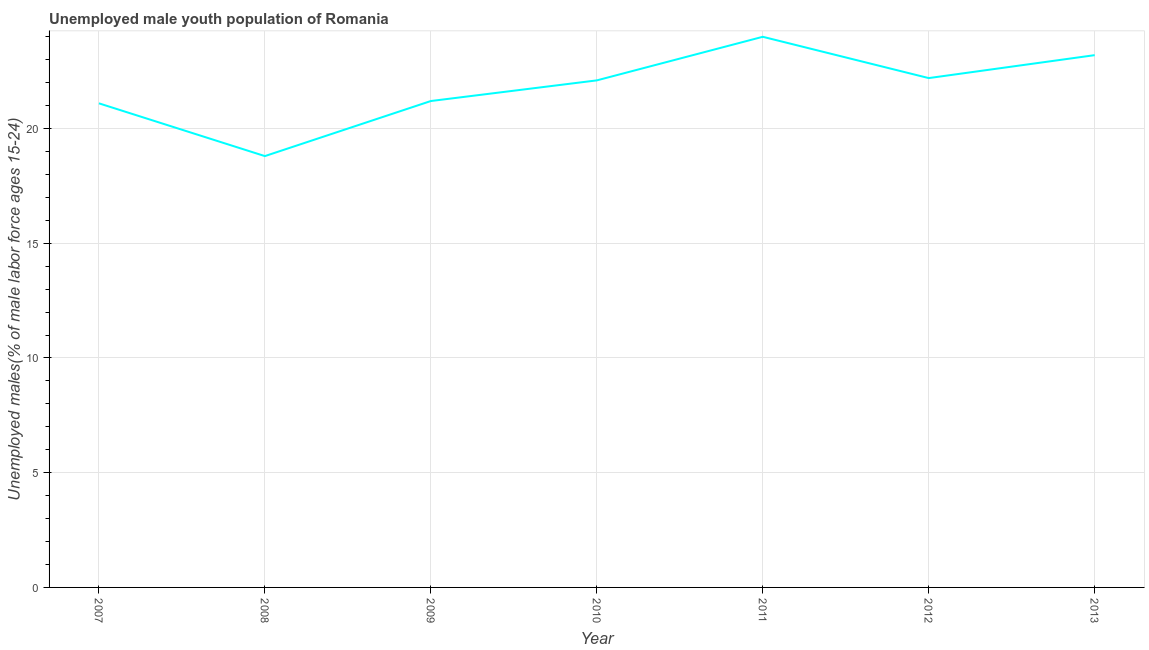What is the unemployed male youth in 2010?
Ensure brevity in your answer.  22.1. Across all years, what is the minimum unemployed male youth?
Offer a terse response. 18.8. What is the sum of the unemployed male youth?
Keep it short and to the point. 152.6. What is the difference between the unemployed male youth in 2008 and 2011?
Your answer should be compact. -5.2. What is the average unemployed male youth per year?
Keep it short and to the point. 21.8. What is the median unemployed male youth?
Ensure brevity in your answer.  22.1. In how many years, is the unemployed male youth greater than 21 %?
Provide a short and direct response. 6. What is the ratio of the unemployed male youth in 2010 to that in 2013?
Make the answer very short. 0.95. Is the unemployed male youth in 2007 less than that in 2011?
Provide a succinct answer. Yes. Is the difference between the unemployed male youth in 2011 and 2012 greater than the difference between any two years?
Keep it short and to the point. No. What is the difference between the highest and the second highest unemployed male youth?
Offer a terse response. 0.8. Is the sum of the unemployed male youth in 2011 and 2012 greater than the maximum unemployed male youth across all years?
Provide a succinct answer. Yes. What is the difference between the highest and the lowest unemployed male youth?
Make the answer very short. 5.2. Does the unemployed male youth monotonically increase over the years?
Provide a short and direct response. No. How many lines are there?
Provide a short and direct response. 1. How many years are there in the graph?
Your response must be concise. 7. What is the title of the graph?
Keep it short and to the point. Unemployed male youth population of Romania. What is the label or title of the Y-axis?
Offer a very short reply. Unemployed males(% of male labor force ages 15-24). What is the Unemployed males(% of male labor force ages 15-24) in 2007?
Provide a short and direct response. 21.1. What is the Unemployed males(% of male labor force ages 15-24) in 2008?
Your answer should be very brief. 18.8. What is the Unemployed males(% of male labor force ages 15-24) in 2009?
Keep it short and to the point. 21.2. What is the Unemployed males(% of male labor force ages 15-24) of 2010?
Your answer should be very brief. 22.1. What is the Unemployed males(% of male labor force ages 15-24) of 2011?
Ensure brevity in your answer.  24. What is the Unemployed males(% of male labor force ages 15-24) in 2012?
Keep it short and to the point. 22.2. What is the Unemployed males(% of male labor force ages 15-24) in 2013?
Ensure brevity in your answer.  23.2. What is the difference between the Unemployed males(% of male labor force ages 15-24) in 2007 and 2008?
Your response must be concise. 2.3. What is the difference between the Unemployed males(% of male labor force ages 15-24) in 2007 and 2009?
Your answer should be very brief. -0.1. What is the difference between the Unemployed males(% of male labor force ages 15-24) in 2007 and 2010?
Provide a short and direct response. -1. What is the difference between the Unemployed males(% of male labor force ages 15-24) in 2007 and 2011?
Provide a succinct answer. -2.9. What is the difference between the Unemployed males(% of male labor force ages 15-24) in 2008 and 2009?
Offer a very short reply. -2.4. What is the difference between the Unemployed males(% of male labor force ages 15-24) in 2008 and 2010?
Ensure brevity in your answer.  -3.3. What is the difference between the Unemployed males(% of male labor force ages 15-24) in 2008 and 2013?
Give a very brief answer. -4.4. What is the difference between the Unemployed males(% of male labor force ages 15-24) in 2009 and 2011?
Offer a very short reply. -2.8. What is the difference between the Unemployed males(% of male labor force ages 15-24) in 2010 and 2011?
Your response must be concise. -1.9. What is the difference between the Unemployed males(% of male labor force ages 15-24) in 2012 and 2013?
Your response must be concise. -1. What is the ratio of the Unemployed males(% of male labor force ages 15-24) in 2007 to that in 2008?
Ensure brevity in your answer.  1.12. What is the ratio of the Unemployed males(% of male labor force ages 15-24) in 2007 to that in 2009?
Offer a terse response. 0.99. What is the ratio of the Unemployed males(% of male labor force ages 15-24) in 2007 to that in 2010?
Offer a very short reply. 0.95. What is the ratio of the Unemployed males(% of male labor force ages 15-24) in 2007 to that in 2011?
Provide a succinct answer. 0.88. What is the ratio of the Unemployed males(% of male labor force ages 15-24) in 2007 to that in 2013?
Provide a succinct answer. 0.91. What is the ratio of the Unemployed males(% of male labor force ages 15-24) in 2008 to that in 2009?
Offer a terse response. 0.89. What is the ratio of the Unemployed males(% of male labor force ages 15-24) in 2008 to that in 2010?
Your answer should be very brief. 0.85. What is the ratio of the Unemployed males(% of male labor force ages 15-24) in 2008 to that in 2011?
Offer a terse response. 0.78. What is the ratio of the Unemployed males(% of male labor force ages 15-24) in 2008 to that in 2012?
Offer a terse response. 0.85. What is the ratio of the Unemployed males(% of male labor force ages 15-24) in 2008 to that in 2013?
Give a very brief answer. 0.81. What is the ratio of the Unemployed males(% of male labor force ages 15-24) in 2009 to that in 2011?
Provide a succinct answer. 0.88. What is the ratio of the Unemployed males(% of male labor force ages 15-24) in 2009 to that in 2012?
Your answer should be very brief. 0.95. What is the ratio of the Unemployed males(% of male labor force ages 15-24) in 2009 to that in 2013?
Keep it short and to the point. 0.91. What is the ratio of the Unemployed males(% of male labor force ages 15-24) in 2010 to that in 2011?
Keep it short and to the point. 0.92. What is the ratio of the Unemployed males(% of male labor force ages 15-24) in 2010 to that in 2013?
Provide a succinct answer. 0.95. What is the ratio of the Unemployed males(% of male labor force ages 15-24) in 2011 to that in 2012?
Give a very brief answer. 1.08. What is the ratio of the Unemployed males(% of male labor force ages 15-24) in 2011 to that in 2013?
Keep it short and to the point. 1.03. 